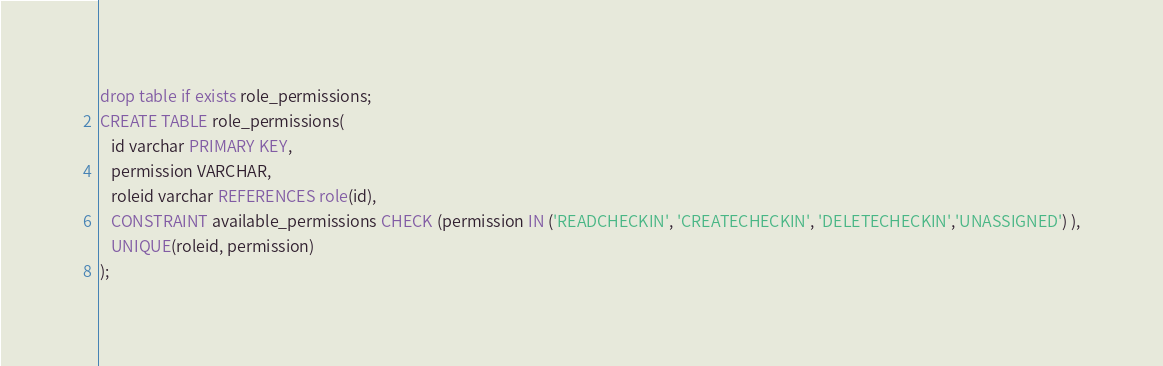Convert code to text. <code><loc_0><loc_0><loc_500><loc_500><_SQL_>drop table if exists role_permissions;
CREATE TABLE role_permissions(
   id varchar PRIMARY KEY,
   permission VARCHAR,
   roleid varchar REFERENCES role(id),
   CONSTRAINT available_permissions CHECK (permission IN ('READCHECKIN', 'CREATECHECKIN', 'DELETECHECKIN','UNASSIGNED') ),
   UNIQUE(roleid, permission)
);</code> 